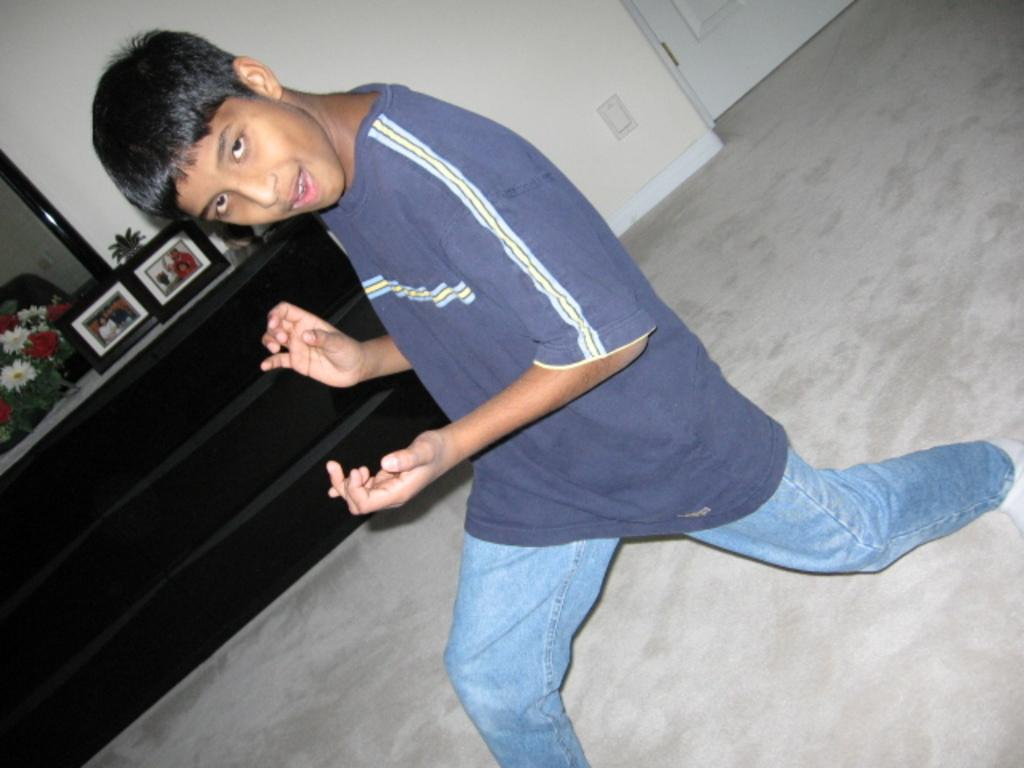Who is present in the image? There is a boy in the image. What is the boy's position in the image? The boy is on the ground. What can be seen in the background of the image? There are frames, flowers, a mirror, a wall, and a door visible in the background of the image. What type of root can be seen growing from the boy's head in the image? There is no root growing from the boy's head in the image; there is no mention of any text or root in the provided facts. 